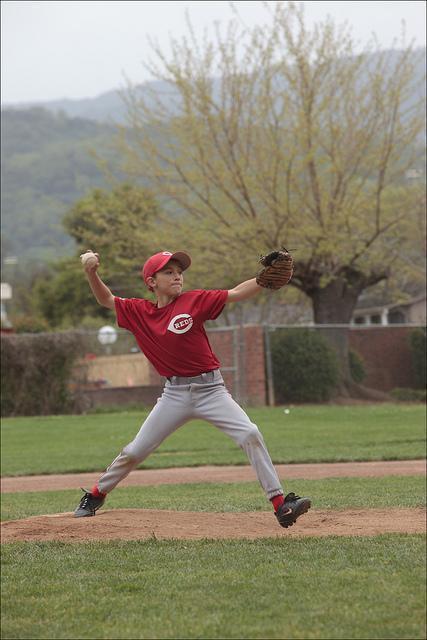How many elephants are to the right of another elephant?
Give a very brief answer. 0. 